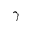Convert formula to latex. <formula><loc_0><loc_0><loc_500><loc_500>\gamma</formula> 